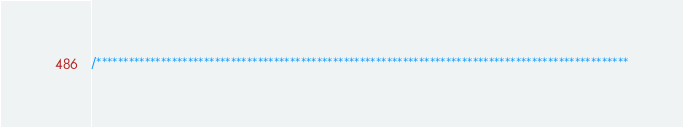<code> <loc_0><loc_0><loc_500><loc_500><_Cuda_>/***************************************************************************************************</code> 